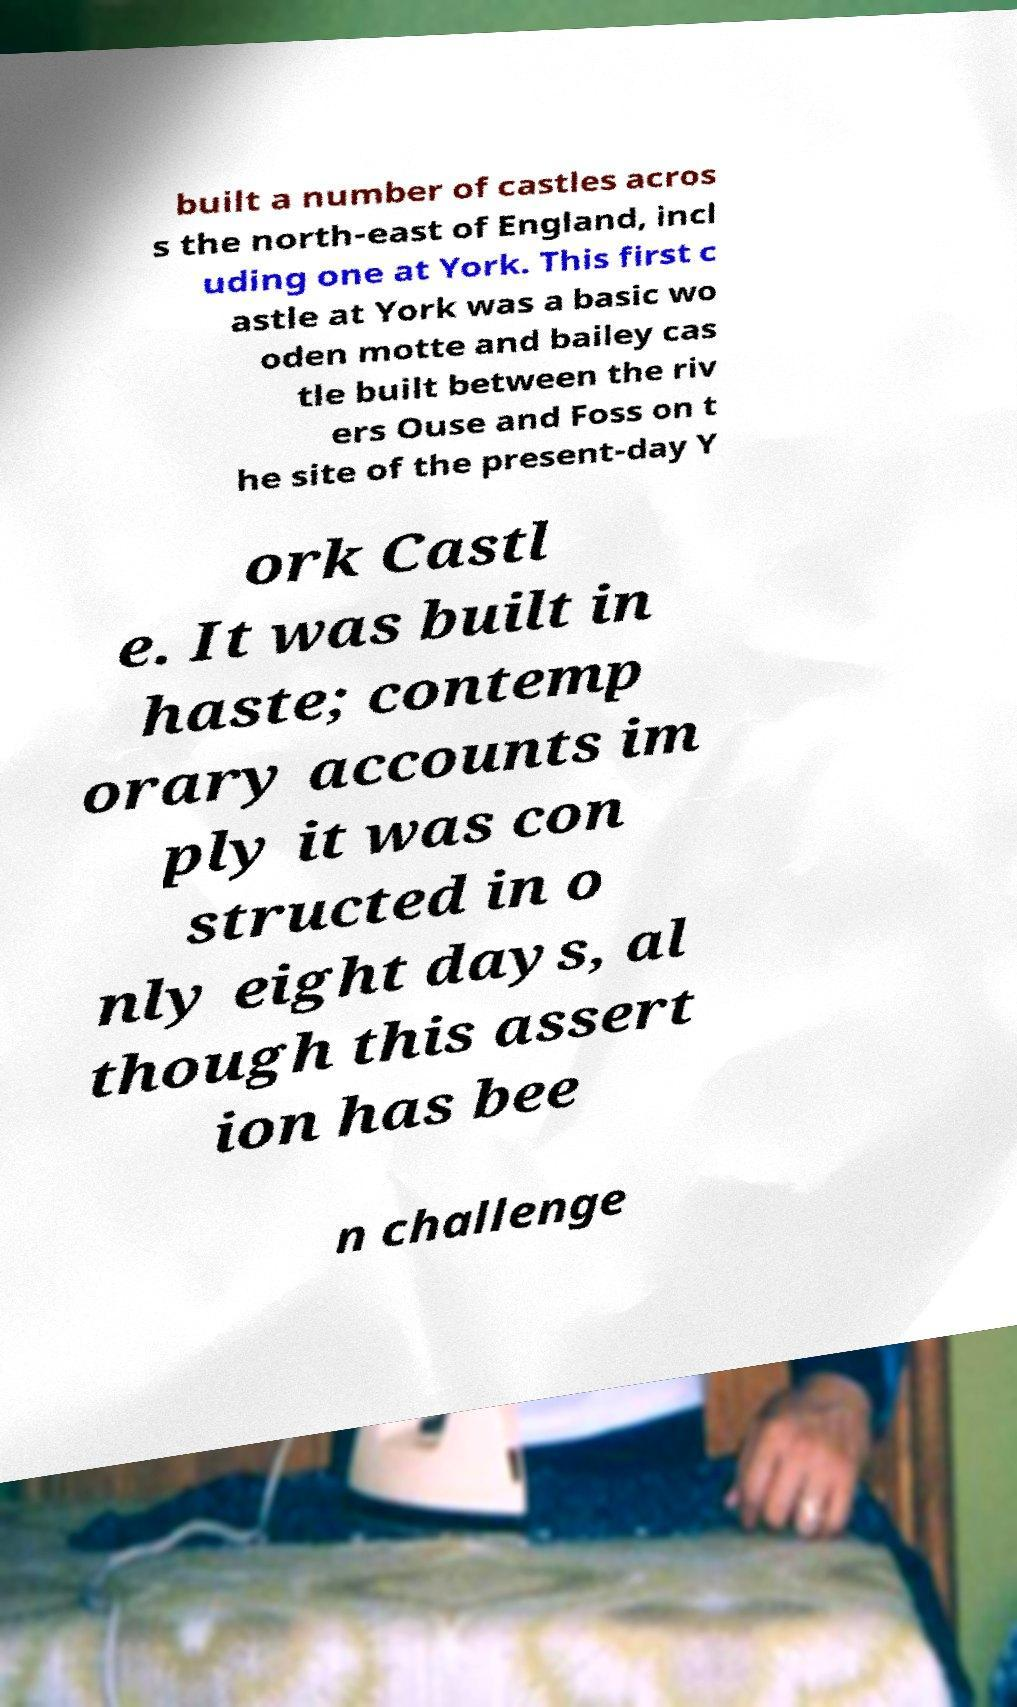Can you accurately transcribe the text from the provided image for me? built a number of castles acros s the north-east of England, incl uding one at York. This first c astle at York was a basic wo oden motte and bailey cas tle built between the riv ers Ouse and Foss on t he site of the present-day Y ork Castl e. It was built in haste; contemp orary accounts im ply it was con structed in o nly eight days, al though this assert ion has bee n challenge 